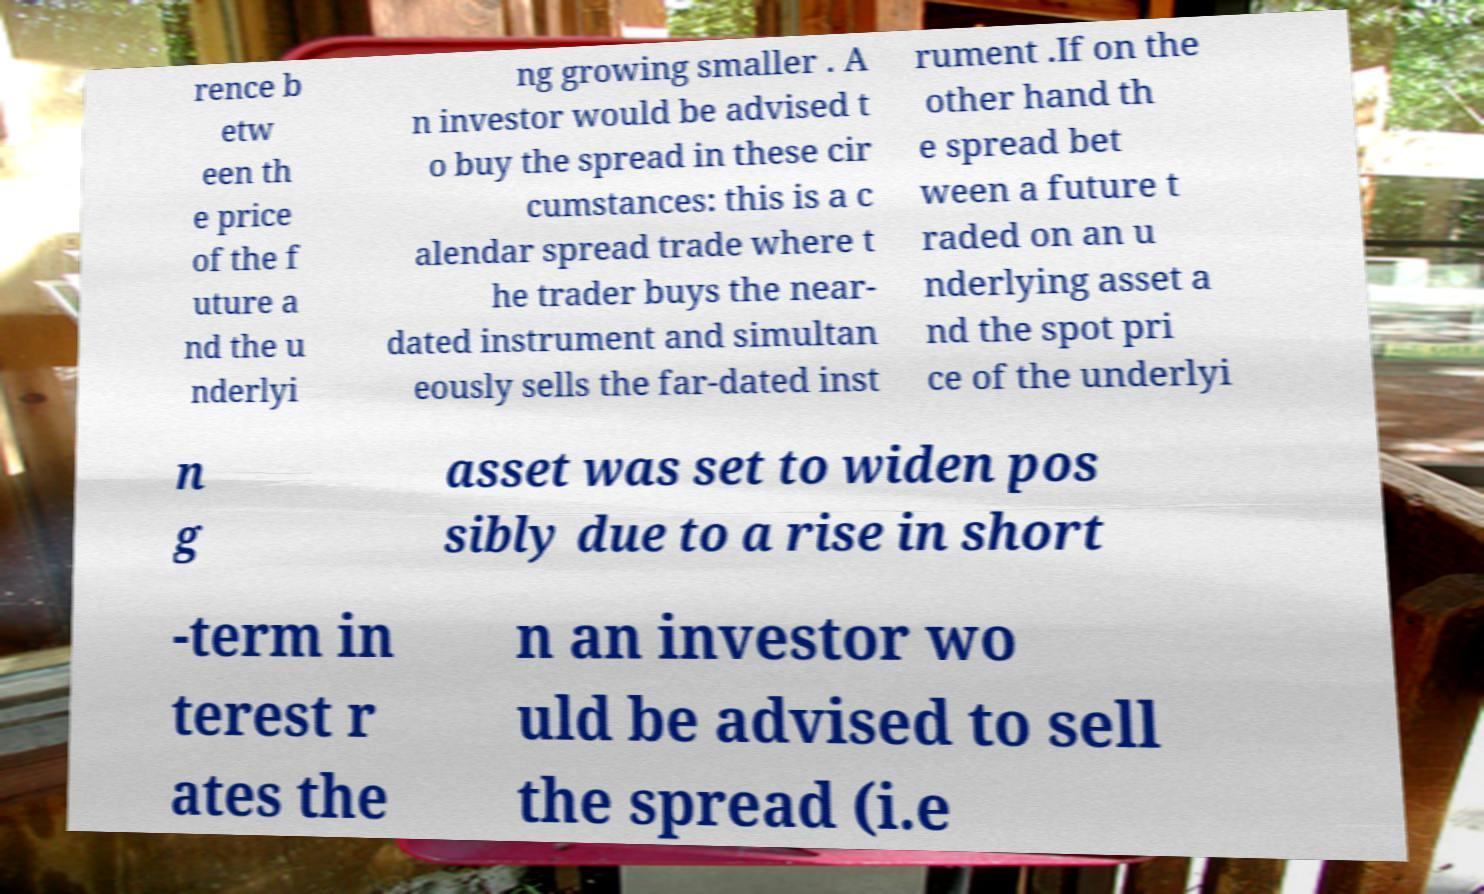There's text embedded in this image that I need extracted. Can you transcribe it verbatim? rence b etw een th e price of the f uture a nd the u nderlyi ng growing smaller . A n investor would be advised t o buy the spread in these cir cumstances: this is a c alendar spread trade where t he trader buys the near- dated instrument and simultan eously sells the far-dated inst rument .If on the other hand th e spread bet ween a future t raded on an u nderlying asset a nd the spot pri ce of the underlyi n g asset was set to widen pos sibly due to a rise in short -term in terest r ates the n an investor wo uld be advised to sell the spread (i.e 